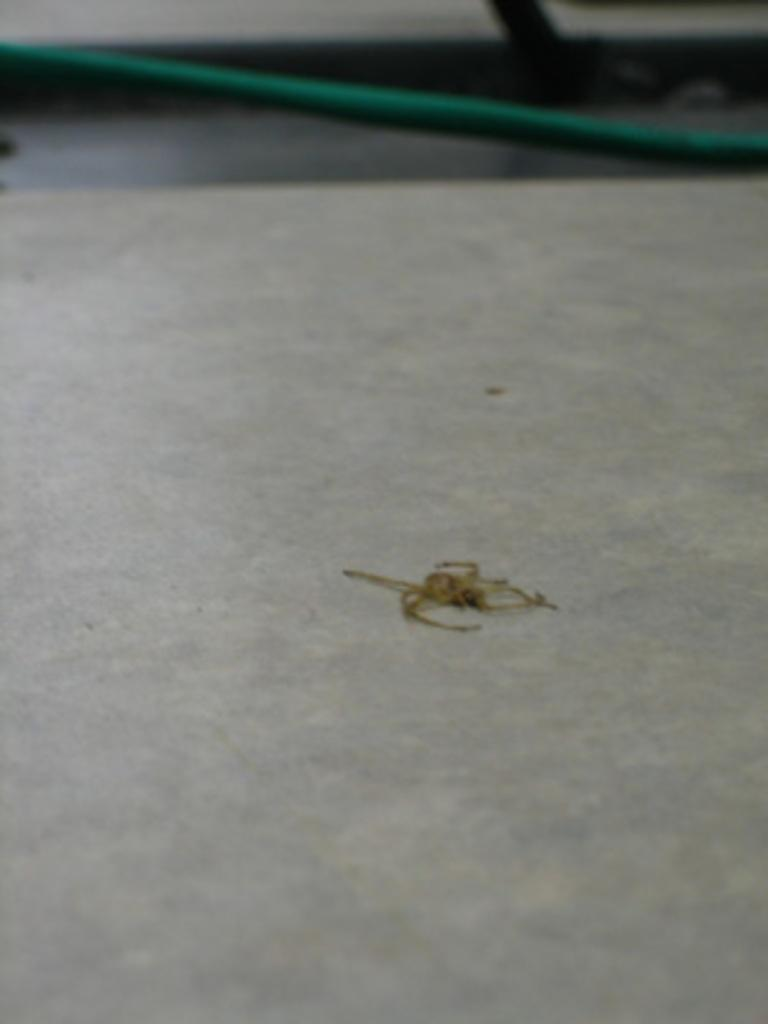What is the color of the surface in the image? The surface in the image is white. What can be seen on the white surface? There is a brown colored object on the surface. What is visible in the background of the image? There is a green pipe in the background of the image. What type of book is the laborer reading in the image? There is no laborer or book present in the image. How does the railway connect to the brown object on the white surface? There is no railway present in the image, so it cannot be connected to the brown object. 